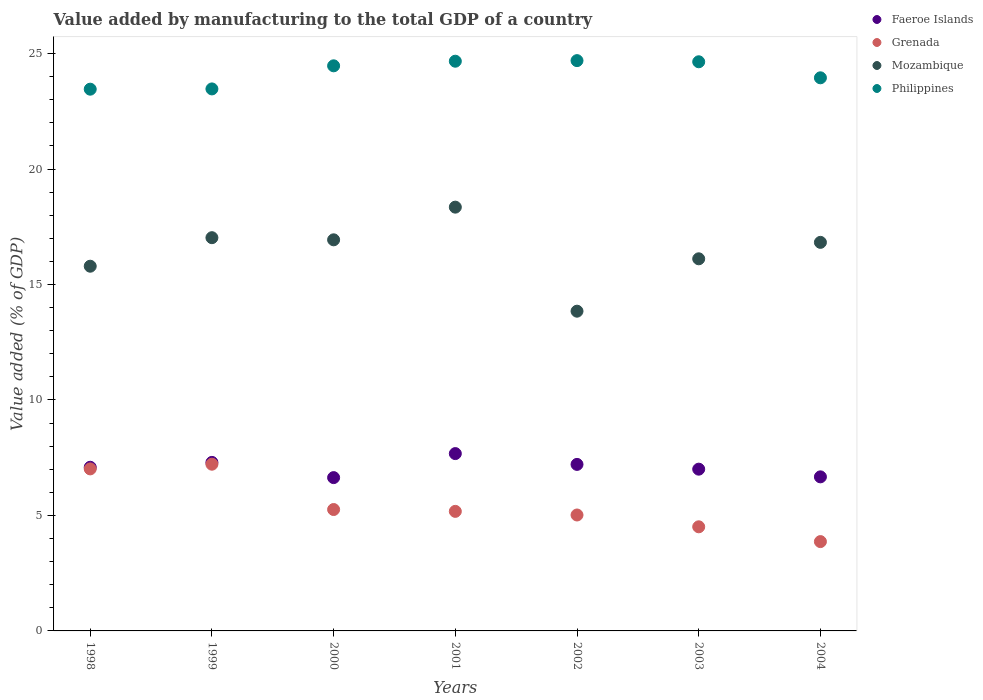How many different coloured dotlines are there?
Provide a short and direct response. 4. Is the number of dotlines equal to the number of legend labels?
Give a very brief answer. Yes. What is the value added by manufacturing to the total GDP in Mozambique in 2004?
Make the answer very short. 16.82. Across all years, what is the maximum value added by manufacturing to the total GDP in Philippines?
Provide a succinct answer. 24.69. Across all years, what is the minimum value added by manufacturing to the total GDP in Faeroe Islands?
Provide a short and direct response. 6.64. In which year was the value added by manufacturing to the total GDP in Mozambique maximum?
Ensure brevity in your answer.  2001. In which year was the value added by manufacturing to the total GDP in Faeroe Islands minimum?
Ensure brevity in your answer.  2000. What is the total value added by manufacturing to the total GDP in Mozambique in the graph?
Provide a succinct answer. 114.88. What is the difference between the value added by manufacturing to the total GDP in Grenada in 1999 and that in 2000?
Ensure brevity in your answer.  1.96. What is the difference between the value added by manufacturing to the total GDP in Faeroe Islands in 2004 and the value added by manufacturing to the total GDP in Mozambique in 2002?
Make the answer very short. -7.17. What is the average value added by manufacturing to the total GDP in Grenada per year?
Provide a short and direct response. 5.44. In the year 1998, what is the difference between the value added by manufacturing to the total GDP in Grenada and value added by manufacturing to the total GDP in Faeroe Islands?
Your answer should be very brief. -0.07. In how many years, is the value added by manufacturing to the total GDP in Philippines greater than 7 %?
Provide a short and direct response. 7. What is the ratio of the value added by manufacturing to the total GDP in Faeroe Islands in 2000 to that in 2004?
Your answer should be very brief. 1. Is the value added by manufacturing to the total GDP in Grenada in 2002 less than that in 2003?
Your answer should be very brief. No. Is the difference between the value added by manufacturing to the total GDP in Grenada in 1999 and 2000 greater than the difference between the value added by manufacturing to the total GDP in Faeroe Islands in 1999 and 2000?
Your answer should be compact. Yes. What is the difference between the highest and the second highest value added by manufacturing to the total GDP in Mozambique?
Offer a very short reply. 1.32. What is the difference between the highest and the lowest value added by manufacturing to the total GDP in Mozambique?
Give a very brief answer. 4.5. In how many years, is the value added by manufacturing to the total GDP in Faeroe Islands greater than the average value added by manufacturing to the total GDP in Faeroe Islands taken over all years?
Your answer should be very brief. 4. Is it the case that in every year, the sum of the value added by manufacturing to the total GDP in Philippines and value added by manufacturing to the total GDP in Grenada  is greater than the value added by manufacturing to the total GDP in Mozambique?
Offer a terse response. Yes. Is the value added by manufacturing to the total GDP in Grenada strictly greater than the value added by manufacturing to the total GDP in Philippines over the years?
Your answer should be compact. No. How many dotlines are there?
Ensure brevity in your answer.  4. Are the values on the major ticks of Y-axis written in scientific E-notation?
Make the answer very short. No. Does the graph contain any zero values?
Offer a very short reply. No. How are the legend labels stacked?
Keep it short and to the point. Vertical. What is the title of the graph?
Keep it short and to the point. Value added by manufacturing to the total GDP of a country. Does "Cameroon" appear as one of the legend labels in the graph?
Provide a succinct answer. No. What is the label or title of the Y-axis?
Offer a terse response. Value added (% of GDP). What is the Value added (% of GDP) of Faeroe Islands in 1998?
Your response must be concise. 7.09. What is the Value added (% of GDP) in Grenada in 1998?
Keep it short and to the point. 7.02. What is the Value added (% of GDP) in Mozambique in 1998?
Provide a succinct answer. 15.79. What is the Value added (% of GDP) in Philippines in 1998?
Keep it short and to the point. 23.46. What is the Value added (% of GDP) of Faeroe Islands in 1999?
Provide a succinct answer. 7.3. What is the Value added (% of GDP) in Grenada in 1999?
Give a very brief answer. 7.22. What is the Value added (% of GDP) in Mozambique in 1999?
Provide a short and direct response. 17.03. What is the Value added (% of GDP) of Philippines in 1999?
Keep it short and to the point. 23.47. What is the Value added (% of GDP) of Faeroe Islands in 2000?
Offer a terse response. 6.64. What is the Value added (% of GDP) in Grenada in 2000?
Give a very brief answer. 5.26. What is the Value added (% of GDP) in Mozambique in 2000?
Your response must be concise. 16.93. What is the Value added (% of GDP) of Philippines in 2000?
Make the answer very short. 24.47. What is the Value added (% of GDP) of Faeroe Islands in 2001?
Provide a short and direct response. 7.68. What is the Value added (% of GDP) of Grenada in 2001?
Make the answer very short. 5.18. What is the Value added (% of GDP) in Mozambique in 2001?
Make the answer very short. 18.35. What is the Value added (% of GDP) in Philippines in 2001?
Provide a short and direct response. 24.67. What is the Value added (% of GDP) of Faeroe Islands in 2002?
Provide a succinct answer. 7.21. What is the Value added (% of GDP) in Grenada in 2002?
Offer a terse response. 5.02. What is the Value added (% of GDP) in Mozambique in 2002?
Your answer should be very brief. 13.84. What is the Value added (% of GDP) of Philippines in 2002?
Offer a very short reply. 24.69. What is the Value added (% of GDP) of Faeroe Islands in 2003?
Provide a short and direct response. 7. What is the Value added (% of GDP) of Grenada in 2003?
Ensure brevity in your answer.  4.51. What is the Value added (% of GDP) of Mozambique in 2003?
Your answer should be compact. 16.11. What is the Value added (% of GDP) of Philippines in 2003?
Keep it short and to the point. 24.64. What is the Value added (% of GDP) of Faeroe Islands in 2004?
Ensure brevity in your answer.  6.67. What is the Value added (% of GDP) of Grenada in 2004?
Provide a succinct answer. 3.87. What is the Value added (% of GDP) in Mozambique in 2004?
Make the answer very short. 16.82. What is the Value added (% of GDP) in Philippines in 2004?
Make the answer very short. 23.95. Across all years, what is the maximum Value added (% of GDP) in Faeroe Islands?
Provide a short and direct response. 7.68. Across all years, what is the maximum Value added (% of GDP) of Grenada?
Provide a short and direct response. 7.22. Across all years, what is the maximum Value added (% of GDP) in Mozambique?
Your answer should be very brief. 18.35. Across all years, what is the maximum Value added (% of GDP) of Philippines?
Ensure brevity in your answer.  24.69. Across all years, what is the minimum Value added (% of GDP) of Faeroe Islands?
Make the answer very short. 6.64. Across all years, what is the minimum Value added (% of GDP) of Grenada?
Offer a terse response. 3.87. Across all years, what is the minimum Value added (% of GDP) in Mozambique?
Provide a succinct answer. 13.84. Across all years, what is the minimum Value added (% of GDP) of Philippines?
Give a very brief answer. 23.46. What is the total Value added (% of GDP) of Faeroe Islands in the graph?
Your answer should be compact. 49.58. What is the total Value added (% of GDP) in Grenada in the graph?
Offer a terse response. 38.06. What is the total Value added (% of GDP) in Mozambique in the graph?
Your answer should be compact. 114.88. What is the total Value added (% of GDP) of Philippines in the graph?
Ensure brevity in your answer.  169.34. What is the difference between the Value added (% of GDP) of Faeroe Islands in 1998 and that in 1999?
Provide a succinct answer. -0.21. What is the difference between the Value added (% of GDP) in Grenada in 1998 and that in 1999?
Offer a very short reply. -0.2. What is the difference between the Value added (% of GDP) of Mozambique in 1998 and that in 1999?
Provide a succinct answer. -1.24. What is the difference between the Value added (% of GDP) of Philippines in 1998 and that in 1999?
Offer a very short reply. -0.01. What is the difference between the Value added (% of GDP) of Faeroe Islands in 1998 and that in 2000?
Offer a terse response. 0.45. What is the difference between the Value added (% of GDP) in Grenada in 1998 and that in 2000?
Provide a succinct answer. 1.76. What is the difference between the Value added (% of GDP) of Mozambique in 1998 and that in 2000?
Provide a short and direct response. -1.14. What is the difference between the Value added (% of GDP) of Philippines in 1998 and that in 2000?
Your answer should be very brief. -1.01. What is the difference between the Value added (% of GDP) in Faeroe Islands in 1998 and that in 2001?
Make the answer very short. -0.59. What is the difference between the Value added (% of GDP) of Grenada in 1998 and that in 2001?
Ensure brevity in your answer.  1.84. What is the difference between the Value added (% of GDP) in Mozambique in 1998 and that in 2001?
Give a very brief answer. -2.56. What is the difference between the Value added (% of GDP) of Philippines in 1998 and that in 2001?
Your response must be concise. -1.21. What is the difference between the Value added (% of GDP) of Faeroe Islands in 1998 and that in 2002?
Make the answer very short. -0.12. What is the difference between the Value added (% of GDP) of Grenada in 1998 and that in 2002?
Your response must be concise. 2. What is the difference between the Value added (% of GDP) of Mozambique in 1998 and that in 2002?
Your answer should be compact. 1.95. What is the difference between the Value added (% of GDP) in Philippines in 1998 and that in 2002?
Ensure brevity in your answer.  -1.24. What is the difference between the Value added (% of GDP) of Faeroe Islands in 1998 and that in 2003?
Ensure brevity in your answer.  0.08. What is the difference between the Value added (% of GDP) of Grenada in 1998 and that in 2003?
Make the answer very short. 2.51. What is the difference between the Value added (% of GDP) in Mozambique in 1998 and that in 2003?
Your answer should be compact. -0.32. What is the difference between the Value added (% of GDP) in Philippines in 1998 and that in 2003?
Your answer should be compact. -1.19. What is the difference between the Value added (% of GDP) of Faeroe Islands in 1998 and that in 2004?
Your answer should be compact. 0.42. What is the difference between the Value added (% of GDP) in Grenada in 1998 and that in 2004?
Ensure brevity in your answer.  3.15. What is the difference between the Value added (% of GDP) in Mozambique in 1998 and that in 2004?
Keep it short and to the point. -1.03. What is the difference between the Value added (% of GDP) in Philippines in 1998 and that in 2004?
Your answer should be very brief. -0.49. What is the difference between the Value added (% of GDP) in Faeroe Islands in 1999 and that in 2000?
Give a very brief answer. 0.66. What is the difference between the Value added (% of GDP) of Grenada in 1999 and that in 2000?
Your answer should be very brief. 1.96. What is the difference between the Value added (% of GDP) in Mozambique in 1999 and that in 2000?
Offer a terse response. 0.09. What is the difference between the Value added (% of GDP) in Philippines in 1999 and that in 2000?
Provide a succinct answer. -1. What is the difference between the Value added (% of GDP) in Faeroe Islands in 1999 and that in 2001?
Offer a terse response. -0.38. What is the difference between the Value added (% of GDP) in Grenada in 1999 and that in 2001?
Provide a succinct answer. 2.04. What is the difference between the Value added (% of GDP) of Mozambique in 1999 and that in 2001?
Your answer should be very brief. -1.32. What is the difference between the Value added (% of GDP) of Philippines in 1999 and that in 2001?
Make the answer very short. -1.2. What is the difference between the Value added (% of GDP) in Faeroe Islands in 1999 and that in 2002?
Give a very brief answer. 0.09. What is the difference between the Value added (% of GDP) in Grenada in 1999 and that in 2002?
Your answer should be compact. 2.2. What is the difference between the Value added (% of GDP) of Mozambique in 1999 and that in 2002?
Ensure brevity in your answer.  3.18. What is the difference between the Value added (% of GDP) of Philippines in 1999 and that in 2002?
Offer a terse response. -1.23. What is the difference between the Value added (% of GDP) of Faeroe Islands in 1999 and that in 2003?
Make the answer very short. 0.29. What is the difference between the Value added (% of GDP) of Grenada in 1999 and that in 2003?
Offer a very short reply. 2.71. What is the difference between the Value added (% of GDP) in Mozambique in 1999 and that in 2003?
Offer a terse response. 0.91. What is the difference between the Value added (% of GDP) of Philippines in 1999 and that in 2003?
Keep it short and to the point. -1.18. What is the difference between the Value added (% of GDP) of Faeroe Islands in 1999 and that in 2004?
Your response must be concise. 0.63. What is the difference between the Value added (% of GDP) of Grenada in 1999 and that in 2004?
Offer a very short reply. 3.35. What is the difference between the Value added (% of GDP) in Mozambique in 1999 and that in 2004?
Your answer should be compact. 0.2. What is the difference between the Value added (% of GDP) in Philippines in 1999 and that in 2004?
Make the answer very short. -0.48. What is the difference between the Value added (% of GDP) in Faeroe Islands in 2000 and that in 2001?
Offer a terse response. -1.04. What is the difference between the Value added (% of GDP) in Grenada in 2000 and that in 2001?
Make the answer very short. 0.08. What is the difference between the Value added (% of GDP) in Mozambique in 2000 and that in 2001?
Your answer should be compact. -1.41. What is the difference between the Value added (% of GDP) in Philippines in 2000 and that in 2001?
Provide a succinct answer. -0.2. What is the difference between the Value added (% of GDP) of Faeroe Islands in 2000 and that in 2002?
Your answer should be very brief. -0.57. What is the difference between the Value added (% of GDP) in Grenada in 2000 and that in 2002?
Keep it short and to the point. 0.24. What is the difference between the Value added (% of GDP) of Mozambique in 2000 and that in 2002?
Offer a very short reply. 3.09. What is the difference between the Value added (% of GDP) of Philippines in 2000 and that in 2002?
Provide a short and direct response. -0.23. What is the difference between the Value added (% of GDP) of Faeroe Islands in 2000 and that in 2003?
Your answer should be very brief. -0.37. What is the difference between the Value added (% of GDP) of Grenada in 2000 and that in 2003?
Your answer should be very brief. 0.75. What is the difference between the Value added (% of GDP) of Mozambique in 2000 and that in 2003?
Keep it short and to the point. 0.82. What is the difference between the Value added (% of GDP) in Philippines in 2000 and that in 2003?
Your answer should be very brief. -0.18. What is the difference between the Value added (% of GDP) of Faeroe Islands in 2000 and that in 2004?
Provide a short and direct response. -0.03. What is the difference between the Value added (% of GDP) in Grenada in 2000 and that in 2004?
Give a very brief answer. 1.39. What is the difference between the Value added (% of GDP) in Mozambique in 2000 and that in 2004?
Your response must be concise. 0.11. What is the difference between the Value added (% of GDP) of Philippines in 2000 and that in 2004?
Your answer should be very brief. 0.52. What is the difference between the Value added (% of GDP) of Faeroe Islands in 2001 and that in 2002?
Provide a short and direct response. 0.47. What is the difference between the Value added (% of GDP) in Grenada in 2001 and that in 2002?
Ensure brevity in your answer.  0.16. What is the difference between the Value added (% of GDP) of Mozambique in 2001 and that in 2002?
Provide a short and direct response. 4.5. What is the difference between the Value added (% of GDP) in Philippines in 2001 and that in 2002?
Offer a very short reply. -0.03. What is the difference between the Value added (% of GDP) of Faeroe Islands in 2001 and that in 2003?
Provide a short and direct response. 0.67. What is the difference between the Value added (% of GDP) of Grenada in 2001 and that in 2003?
Offer a terse response. 0.67. What is the difference between the Value added (% of GDP) in Mozambique in 2001 and that in 2003?
Offer a very short reply. 2.24. What is the difference between the Value added (% of GDP) of Philippines in 2001 and that in 2003?
Your answer should be very brief. 0.02. What is the difference between the Value added (% of GDP) of Faeroe Islands in 2001 and that in 2004?
Your answer should be very brief. 1.01. What is the difference between the Value added (% of GDP) in Grenada in 2001 and that in 2004?
Keep it short and to the point. 1.31. What is the difference between the Value added (% of GDP) in Mozambique in 2001 and that in 2004?
Offer a very short reply. 1.52. What is the difference between the Value added (% of GDP) of Philippines in 2001 and that in 2004?
Your response must be concise. 0.72. What is the difference between the Value added (% of GDP) in Faeroe Islands in 2002 and that in 2003?
Make the answer very short. 0.21. What is the difference between the Value added (% of GDP) in Grenada in 2002 and that in 2003?
Offer a terse response. 0.51. What is the difference between the Value added (% of GDP) of Mozambique in 2002 and that in 2003?
Provide a succinct answer. -2.27. What is the difference between the Value added (% of GDP) of Philippines in 2002 and that in 2003?
Your answer should be compact. 0.05. What is the difference between the Value added (% of GDP) in Faeroe Islands in 2002 and that in 2004?
Offer a terse response. 0.54. What is the difference between the Value added (% of GDP) of Grenada in 2002 and that in 2004?
Provide a succinct answer. 1.15. What is the difference between the Value added (% of GDP) of Mozambique in 2002 and that in 2004?
Offer a very short reply. -2.98. What is the difference between the Value added (% of GDP) of Philippines in 2002 and that in 2004?
Ensure brevity in your answer.  0.74. What is the difference between the Value added (% of GDP) in Faeroe Islands in 2003 and that in 2004?
Offer a very short reply. 0.33. What is the difference between the Value added (% of GDP) in Grenada in 2003 and that in 2004?
Your answer should be compact. 0.64. What is the difference between the Value added (% of GDP) of Mozambique in 2003 and that in 2004?
Offer a terse response. -0.71. What is the difference between the Value added (% of GDP) in Philippines in 2003 and that in 2004?
Your answer should be very brief. 0.69. What is the difference between the Value added (% of GDP) in Faeroe Islands in 1998 and the Value added (% of GDP) in Grenada in 1999?
Your response must be concise. -0.13. What is the difference between the Value added (% of GDP) in Faeroe Islands in 1998 and the Value added (% of GDP) in Mozambique in 1999?
Offer a very short reply. -9.94. What is the difference between the Value added (% of GDP) of Faeroe Islands in 1998 and the Value added (% of GDP) of Philippines in 1999?
Offer a terse response. -16.38. What is the difference between the Value added (% of GDP) in Grenada in 1998 and the Value added (% of GDP) in Mozambique in 1999?
Give a very brief answer. -10.01. What is the difference between the Value added (% of GDP) in Grenada in 1998 and the Value added (% of GDP) in Philippines in 1999?
Offer a very short reply. -16.45. What is the difference between the Value added (% of GDP) in Mozambique in 1998 and the Value added (% of GDP) in Philippines in 1999?
Provide a succinct answer. -7.68. What is the difference between the Value added (% of GDP) in Faeroe Islands in 1998 and the Value added (% of GDP) in Grenada in 2000?
Make the answer very short. 1.83. What is the difference between the Value added (% of GDP) in Faeroe Islands in 1998 and the Value added (% of GDP) in Mozambique in 2000?
Your answer should be very brief. -9.85. What is the difference between the Value added (% of GDP) of Faeroe Islands in 1998 and the Value added (% of GDP) of Philippines in 2000?
Provide a succinct answer. -17.38. What is the difference between the Value added (% of GDP) of Grenada in 1998 and the Value added (% of GDP) of Mozambique in 2000?
Provide a short and direct response. -9.92. What is the difference between the Value added (% of GDP) in Grenada in 1998 and the Value added (% of GDP) in Philippines in 2000?
Keep it short and to the point. -17.45. What is the difference between the Value added (% of GDP) in Mozambique in 1998 and the Value added (% of GDP) in Philippines in 2000?
Your answer should be very brief. -8.68. What is the difference between the Value added (% of GDP) in Faeroe Islands in 1998 and the Value added (% of GDP) in Grenada in 2001?
Your answer should be compact. 1.91. What is the difference between the Value added (% of GDP) in Faeroe Islands in 1998 and the Value added (% of GDP) in Mozambique in 2001?
Your response must be concise. -11.26. What is the difference between the Value added (% of GDP) in Faeroe Islands in 1998 and the Value added (% of GDP) in Philippines in 2001?
Your answer should be very brief. -17.58. What is the difference between the Value added (% of GDP) in Grenada in 1998 and the Value added (% of GDP) in Mozambique in 2001?
Make the answer very short. -11.33. What is the difference between the Value added (% of GDP) of Grenada in 1998 and the Value added (% of GDP) of Philippines in 2001?
Your answer should be compact. -17.65. What is the difference between the Value added (% of GDP) in Mozambique in 1998 and the Value added (% of GDP) in Philippines in 2001?
Provide a short and direct response. -8.88. What is the difference between the Value added (% of GDP) of Faeroe Islands in 1998 and the Value added (% of GDP) of Grenada in 2002?
Offer a terse response. 2.07. What is the difference between the Value added (% of GDP) of Faeroe Islands in 1998 and the Value added (% of GDP) of Mozambique in 2002?
Give a very brief answer. -6.76. What is the difference between the Value added (% of GDP) in Faeroe Islands in 1998 and the Value added (% of GDP) in Philippines in 2002?
Keep it short and to the point. -17.61. What is the difference between the Value added (% of GDP) in Grenada in 1998 and the Value added (% of GDP) in Mozambique in 2002?
Provide a short and direct response. -6.83. What is the difference between the Value added (% of GDP) of Grenada in 1998 and the Value added (% of GDP) of Philippines in 2002?
Your answer should be compact. -17.68. What is the difference between the Value added (% of GDP) of Mozambique in 1998 and the Value added (% of GDP) of Philippines in 2002?
Your answer should be compact. -8.9. What is the difference between the Value added (% of GDP) of Faeroe Islands in 1998 and the Value added (% of GDP) of Grenada in 2003?
Make the answer very short. 2.58. What is the difference between the Value added (% of GDP) of Faeroe Islands in 1998 and the Value added (% of GDP) of Mozambique in 2003?
Provide a succinct answer. -9.03. What is the difference between the Value added (% of GDP) in Faeroe Islands in 1998 and the Value added (% of GDP) in Philippines in 2003?
Make the answer very short. -17.56. What is the difference between the Value added (% of GDP) in Grenada in 1998 and the Value added (% of GDP) in Mozambique in 2003?
Offer a terse response. -9.1. What is the difference between the Value added (% of GDP) in Grenada in 1998 and the Value added (% of GDP) in Philippines in 2003?
Provide a succinct answer. -17.63. What is the difference between the Value added (% of GDP) in Mozambique in 1998 and the Value added (% of GDP) in Philippines in 2003?
Keep it short and to the point. -8.85. What is the difference between the Value added (% of GDP) of Faeroe Islands in 1998 and the Value added (% of GDP) of Grenada in 2004?
Offer a terse response. 3.22. What is the difference between the Value added (% of GDP) of Faeroe Islands in 1998 and the Value added (% of GDP) of Mozambique in 2004?
Provide a succinct answer. -9.74. What is the difference between the Value added (% of GDP) in Faeroe Islands in 1998 and the Value added (% of GDP) in Philippines in 2004?
Keep it short and to the point. -16.86. What is the difference between the Value added (% of GDP) in Grenada in 1998 and the Value added (% of GDP) in Mozambique in 2004?
Keep it short and to the point. -9.81. What is the difference between the Value added (% of GDP) of Grenada in 1998 and the Value added (% of GDP) of Philippines in 2004?
Offer a terse response. -16.93. What is the difference between the Value added (% of GDP) of Mozambique in 1998 and the Value added (% of GDP) of Philippines in 2004?
Keep it short and to the point. -8.16. What is the difference between the Value added (% of GDP) in Faeroe Islands in 1999 and the Value added (% of GDP) in Grenada in 2000?
Offer a very short reply. 2.04. What is the difference between the Value added (% of GDP) of Faeroe Islands in 1999 and the Value added (% of GDP) of Mozambique in 2000?
Offer a terse response. -9.64. What is the difference between the Value added (% of GDP) in Faeroe Islands in 1999 and the Value added (% of GDP) in Philippines in 2000?
Offer a very short reply. -17.17. What is the difference between the Value added (% of GDP) of Grenada in 1999 and the Value added (% of GDP) of Mozambique in 2000?
Your answer should be compact. -9.72. What is the difference between the Value added (% of GDP) in Grenada in 1999 and the Value added (% of GDP) in Philippines in 2000?
Keep it short and to the point. -17.25. What is the difference between the Value added (% of GDP) of Mozambique in 1999 and the Value added (% of GDP) of Philippines in 2000?
Offer a very short reply. -7.44. What is the difference between the Value added (% of GDP) of Faeroe Islands in 1999 and the Value added (% of GDP) of Grenada in 2001?
Offer a terse response. 2.12. What is the difference between the Value added (% of GDP) of Faeroe Islands in 1999 and the Value added (% of GDP) of Mozambique in 2001?
Provide a succinct answer. -11.05. What is the difference between the Value added (% of GDP) of Faeroe Islands in 1999 and the Value added (% of GDP) of Philippines in 2001?
Ensure brevity in your answer.  -17.37. What is the difference between the Value added (% of GDP) of Grenada in 1999 and the Value added (% of GDP) of Mozambique in 2001?
Keep it short and to the point. -11.13. What is the difference between the Value added (% of GDP) in Grenada in 1999 and the Value added (% of GDP) in Philippines in 2001?
Your answer should be very brief. -17.45. What is the difference between the Value added (% of GDP) of Mozambique in 1999 and the Value added (% of GDP) of Philippines in 2001?
Offer a terse response. -7.64. What is the difference between the Value added (% of GDP) in Faeroe Islands in 1999 and the Value added (% of GDP) in Grenada in 2002?
Keep it short and to the point. 2.28. What is the difference between the Value added (% of GDP) in Faeroe Islands in 1999 and the Value added (% of GDP) in Mozambique in 2002?
Offer a very short reply. -6.55. What is the difference between the Value added (% of GDP) of Faeroe Islands in 1999 and the Value added (% of GDP) of Philippines in 2002?
Offer a terse response. -17.4. What is the difference between the Value added (% of GDP) of Grenada in 1999 and the Value added (% of GDP) of Mozambique in 2002?
Make the answer very short. -6.63. What is the difference between the Value added (% of GDP) in Grenada in 1999 and the Value added (% of GDP) in Philippines in 2002?
Give a very brief answer. -17.47. What is the difference between the Value added (% of GDP) of Mozambique in 1999 and the Value added (% of GDP) of Philippines in 2002?
Give a very brief answer. -7.67. What is the difference between the Value added (% of GDP) in Faeroe Islands in 1999 and the Value added (% of GDP) in Grenada in 2003?
Offer a very short reply. 2.79. What is the difference between the Value added (% of GDP) in Faeroe Islands in 1999 and the Value added (% of GDP) in Mozambique in 2003?
Your answer should be compact. -8.82. What is the difference between the Value added (% of GDP) in Faeroe Islands in 1999 and the Value added (% of GDP) in Philippines in 2003?
Give a very brief answer. -17.35. What is the difference between the Value added (% of GDP) of Grenada in 1999 and the Value added (% of GDP) of Mozambique in 2003?
Your response must be concise. -8.89. What is the difference between the Value added (% of GDP) in Grenada in 1999 and the Value added (% of GDP) in Philippines in 2003?
Keep it short and to the point. -17.42. What is the difference between the Value added (% of GDP) of Mozambique in 1999 and the Value added (% of GDP) of Philippines in 2003?
Keep it short and to the point. -7.62. What is the difference between the Value added (% of GDP) in Faeroe Islands in 1999 and the Value added (% of GDP) in Grenada in 2004?
Your answer should be compact. 3.43. What is the difference between the Value added (% of GDP) in Faeroe Islands in 1999 and the Value added (% of GDP) in Mozambique in 2004?
Provide a short and direct response. -9.53. What is the difference between the Value added (% of GDP) in Faeroe Islands in 1999 and the Value added (% of GDP) in Philippines in 2004?
Give a very brief answer. -16.65. What is the difference between the Value added (% of GDP) in Grenada in 1999 and the Value added (% of GDP) in Mozambique in 2004?
Provide a short and direct response. -9.61. What is the difference between the Value added (% of GDP) of Grenada in 1999 and the Value added (% of GDP) of Philippines in 2004?
Make the answer very short. -16.73. What is the difference between the Value added (% of GDP) of Mozambique in 1999 and the Value added (% of GDP) of Philippines in 2004?
Make the answer very short. -6.92. What is the difference between the Value added (% of GDP) in Faeroe Islands in 2000 and the Value added (% of GDP) in Grenada in 2001?
Your response must be concise. 1.46. What is the difference between the Value added (% of GDP) in Faeroe Islands in 2000 and the Value added (% of GDP) in Mozambique in 2001?
Your answer should be very brief. -11.71. What is the difference between the Value added (% of GDP) in Faeroe Islands in 2000 and the Value added (% of GDP) in Philippines in 2001?
Ensure brevity in your answer.  -18.03. What is the difference between the Value added (% of GDP) of Grenada in 2000 and the Value added (% of GDP) of Mozambique in 2001?
Make the answer very short. -13.09. What is the difference between the Value added (% of GDP) of Grenada in 2000 and the Value added (% of GDP) of Philippines in 2001?
Keep it short and to the point. -19.41. What is the difference between the Value added (% of GDP) of Mozambique in 2000 and the Value added (% of GDP) of Philippines in 2001?
Give a very brief answer. -7.73. What is the difference between the Value added (% of GDP) of Faeroe Islands in 2000 and the Value added (% of GDP) of Grenada in 2002?
Make the answer very short. 1.62. What is the difference between the Value added (% of GDP) of Faeroe Islands in 2000 and the Value added (% of GDP) of Mozambique in 2002?
Ensure brevity in your answer.  -7.21. What is the difference between the Value added (% of GDP) in Faeroe Islands in 2000 and the Value added (% of GDP) in Philippines in 2002?
Give a very brief answer. -18.05. What is the difference between the Value added (% of GDP) in Grenada in 2000 and the Value added (% of GDP) in Mozambique in 2002?
Give a very brief answer. -8.59. What is the difference between the Value added (% of GDP) of Grenada in 2000 and the Value added (% of GDP) of Philippines in 2002?
Provide a short and direct response. -19.44. What is the difference between the Value added (% of GDP) in Mozambique in 2000 and the Value added (% of GDP) in Philippines in 2002?
Offer a terse response. -7.76. What is the difference between the Value added (% of GDP) of Faeroe Islands in 2000 and the Value added (% of GDP) of Grenada in 2003?
Your answer should be very brief. 2.13. What is the difference between the Value added (% of GDP) of Faeroe Islands in 2000 and the Value added (% of GDP) of Mozambique in 2003?
Make the answer very short. -9.47. What is the difference between the Value added (% of GDP) of Faeroe Islands in 2000 and the Value added (% of GDP) of Philippines in 2003?
Offer a terse response. -18. What is the difference between the Value added (% of GDP) of Grenada in 2000 and the Value added (% of GDP) of Mozambique in 2003?
Your response must be concise. -10.86. What is the difference between the Value added (% of GDP) in Grenada in 2000 and the Value added (% of GDP) in Philippines in 2003?
Give a very brief answer. -19.39. What is the difference between the Value added (% of GDP) in Mozambique in 2000 and the Value added (% of GDP) in Philippines in 2003?
Keep it short and to the point. -7.71. What is the difference between the Value added (% of GDP) in Faeroe Islands in 2000 and the Value added (% of GDP) in Grenada in 2004?
Provide a succinct answer. 2.77. What is the difference between the Value added (% of GDP) of Faeroe Islands in 2000 and the Value added (% of GDP) of Mozambique in 2004?
Give a very brief answer. -10.19. What is the difference between the Value added (% of GDP) of Faeroe Islands in 2000 and the Value added (% of GDP) of Philippines in 2004?
Give a very brief answer. -17.31. What is the difference between the Value added (% of GDP) of Grenada in 2000 and the Value added (% of GDP) of Mozambique in 2004?
Provide a succinct answer. -11.57. What is the difference between the Value added (% of GDP) in Grenada in 2000 and the Value added (% of GDP) in Philippines in 2004?
Your answer should be very brief. -18.69. What is the difference between the Value added (% of GDP) in Mozambique in 2000 and the Value added (% of GDP) in Philippines in 2004?
Make the answer very short. -7.01. What is the difference between the Value added (% of GDP) of Faeroe Islands in 2001 and the Value added (% of GDP) of Grenada in 2002?
Offer a terse response. 2.66. What is the difference between the Value added (% of GDP) of Faeroe Islands in 2001 and the Value added (% of GDP) of Mozambique in 2002?
Provide a short and direct response. -6.17. What is the difference between the Value added (% of GDP) of Faeroe Islands in 2001 and the Value added (% of GDP) of Philippines in 2002?
Ensure brevity in your answer.  -17.01. What is the difference between the Value added (% of GDP) of Grenada in 2001 and the Value added (% of GDP) of Mozambique in 2002?
Offer a terse response. -8.67. What is the difference between the Value added (% of GDP) of Grenada in 2001 and the Value added (% of GDP) of Philippines in 2002?
Your response must be concise. -19.52. What is the difference between the Value added (% of GDP) of Mozambique in 2001 and the Value added (% of GDP) of Philippines in 2002?
Give a very brief answer. -6.34. What is the difference between the Value added (% of GDP) of Faeroe Islands in 2001 and the Value added (% of GDP) of Grenada in 2003?
Your answer should be very brief. 3.17. What is the difference between the Value added (% of GDP) in Faeroe Islands in 2001 and the Value added (% of GDP) in Mozambique in 2003?
Your answer should be compact. -8.43. What is the difference between the Value added (% of GDP) of Faeroe Islands in 2001 and the Value added (% of GDP) of Philippines in 2003?
Offer a terse response. -16.96. What is the difference between the Value added (% of GDP) of Grenada in 2001 and the Value added (% of GDP) of Mozambique in 2003?
Give a very brief answer. -10.94. What is the difference between the Value added (% of GDP) in Grenada in 2001 and the Value added (% of GDP) in Philippines in 2003?
Offer a terse response. -19.47. What is the difference between the Value added (% of GDP) in Mozambique in 2001 and the Value added (% of GDP) in Philippines in 2003?
Ensure brevity in your answer.  -6.29. What is the difference between the Value added (% of GDP) of Faeroe Islands in 2001 and the Value added (% of GDP) of Grenada in 2004?
Your response must be concise. 3.81. What is the difference between the Value added (% of GDP) in Faeroe Islands in 2001 and the Value added (% of GDP) in Mozambique in 2004?
Your answer should be very brief. -9.15. What is the difference between the Value added (% of GDP) of Faeroe Islands in 2001 and the Value added (% of GDP) of Philippines in 2004?
Ensure brevity in your answer.  -16.27. What is the difference between the Value added (% of GDP) in Grenada in 2001 and the Value added (% of GDP) in Mozambique in 2004?
Offer a very short reply. -11.65. What is the difference between the Value added (% of GDP) in Grenada in 2001 and the Value added (% of GDP) in Philippines in 2004?
Make the answer very short. -18.77. What is the difference between the Value added (% of GDP) in Mozambique in 2001 and the Value added (% of GDP) in Philippines in 2004?
Offer a very short reply. -5.6. What is the difference between the Value added (% of GDP) of Faeroe Islands in 2002 and the Value added (% of GDP) of Grenada in 2003?
Keep it short and to the point. 2.7. What is the difference between the Value added (% of GDP) of Faeroe Islands in 2002 and the Value added (% of GDP) of Mozambique in 2003?
Offer a very short reply. -8.9. What is the difference between the Value added (% of GDP) of Faeroe Islands in 2002 and the Value added (% of GDP) of Philippines in 2003?
Your answer should be compact. -17.43. What is the difference between the Value added (% of GDP) in Grenada in 2002 and the Value added (% of GDP) in Mozambique in 2003?
Keep it short and to the point. -11.09. What is the difference between the Value added (% of GDP) of Grenada in 2002 and the Value added (% of GDP) of Philippines in 2003?
Keep it short and to the point. -19.62. What is the difference between the Value added (% of GDP) in Mozambique in 2002 and the Value added (% of GDP) in Philippines in 2003?
Keep it short and to the point. -10.8. What is the difference between the Value added (% of GDP) of Faeroe Islands in 2002 and the Value added (% of GDP) of Grenada in 2004?
Provide a succinct answer. 3.34. What is the difference between the Value added (% of GDP) of Faeroe Islands in 2002 and the Value added (% of GDP) of Mozambique in 2004?
Provide a short and direct response. -9.61. What is the difference between the Value added (% of GDP) in Faeroe Islands in 2002 and the Value added (% of GDP) in Philippines in 2004?
Provide a short and direct response. -16.74. What is the difference between the Value added (% of GDP) of Grenada in 2002 and the Value added (% of GDP) of Mozambique in 2004?
Keep it short and to the point. -11.8. What is the difference between the Value added (% of GDP) in Grenada in 2002 and the Value added (% of GDP) in Philippines in 2004?
Give a very brief answer. -18.93. What is the difference between the Value added (% of GDP) of Mozambique in 2002 and the Value added (% of GDP) of Philippines in 2004?
Your answer should be very brief. -10.1. What is the difference between the Value added (% of GDP) of Faeroe Islands in 2003 and the Value added (% of GDP) of Grenada in 2004?
Provide a short and direct response. 3.14. What is the difference between the Value added (% of GDP) in Faeroe Islands in 2003 and the Value added (% of GDP) in Mozambique in 2004?
Your answer should be very brief. -9.82. What is the difference between the Value added (% of GDP) in Faeroe Islands in 2003 and the Value added (% of GDP) in Philippines in 2004?
Provide a short and direct response. -16.94. What is the difference between the Value added (% of GDP) in Grenada in 2003 and the Value added (% of GDP) in Mozambique in 2004?
Make the answer very short. -12.32. What is the difference between the Value added (% of GDP) in Grenada in 2003 and the Value added (% of GDP) in Philippines in 2004?
Offer a very short reply. -19.44. What is the difference between the Value added (% of GDP) of Mozambique in 2003 and the Value added (% of GDP) of Philippines in 2004?
Give a very brief answer. -7.84. What is the average Value added (% of GDP) of Faeroe Islands per year?
Your response must be concise. 7.08. What is the average Value added (% of GDP) of Grenada per year?
Offer a terse response. 5.44. What is the average Value added (% of GDP) in Mozambique per year?
Your response must be concise. 16.41. What is the average Value added (% of GDP) in Philippines per year?
Your answer should be compact. 24.19. In the year 1998, what is the difference between the Value added (% of GDP) in Faeroe Islands and Value added (% of GDP) in Grenada?
Provide a short and direct response. 0.07. In the year 1998, what is the difference between the Value added (% of GDP) in Faeroe Islands and Value added (% of GDP) in Mozambique?
Ensure brevity in your answer.  -8.7. In the year 1998, what is the difference between the Value added (% of GDP) of Faeroe Islands and Value added (% of GDP) of Philippines?
Your response must be concise. -16.37. In the year 1998, what is the difference between the Value added (% of GDP) of Grenada and Value added (% of GDP) of Mozambique?
Provide a short and direct response. -8.78. In the year 1998, what is the difference between the Value added (% of GDP) in Grenada and Value added (% of GDP) in Philippines?
Give a very brief answer. -16.44. In the year 1998, what is the difference between the Value added (% of GDP) in Mozambique and Value added (% of GDP) in Philippines?
Ensure brevity in your answer.  -7.67. In the year 1999, what is the difference between the Value added (% of GDP) of Faeroe Islands and Value added (% of GDP) of Grenada?
Ensure brevity in your answer.  0.08. In the year 1999, what is the difference between the Value added (% of GDP) in Faeroe Islands and Value added (% of GDP) in Mozambique?
Give a very brief answer. -9.73. In the year 1999, what is the difference between the Value added (% of GDP) of Faeroe Islands and Value added (% of GDP) of Philippines?
Offer a very short reply. -16.17. In the year 1999, what is the difference between the Value added (% of GDP) in Grenada and Value added (% of GDP) in Mozambique?
Keep it short and to the point. -9.81. In the year 1999, what is the difference between the Value added (% of GDP) of Grenada and Value added (% of GDP) of Philippines?
Your answer should be very brief. -16.25. In the year 1999, what is the difference between the Value added (% of GDP) in Mozambique and Value added (% of GDP) in Philippines?
Offer a very short reply. -6.44. In the year 2000, what is the difference between the Value added (% of GDP) in Faeroe Islands and Value added (% of GDP) in Grenada?
Give a very brief answer. 1.38. In the year 2000, what is the difference between the Value added (% of GDP) in Faeroe Islands and Value added (% of GDP) in Mozambique?
Provide a short and direct response. -10.3. In the year 2000, what is the difference between the Value added (% of GDP) of Faeroe Islands and Value added (% of GDP) of Philippines?
Offer a very short reply. -17.83. In the year 2000, what is the difference between the Value added (% of GDP) of Grenada and Value added (% of GDP) of Mozambique?
Your response must be concise. -11.68. In the year 2000, what is the difference between the Value added (% of GDP) in Grenada and Value added (% of GDP) in Philippines?
Offer a very short reply. -19.21. In the year 2000, what is the difference between the Value added (% of GDP) in Mozambique and Value added (% of GDP) in Philippines?
Ensure brevity in your answer.  -7.53. In the year 2001, what is the difference between the Value added (% of GDP) in Faeroe Islands and Value added (% of GDP) in Grenada?
Offer a very short reply. 2.5. In the year 2001, what is the difference between the Value added (% of GDP) in Faeroe Islands and Value added (% of GDP) in Mozambique?
Your answer should be compact. -10.67. In the year 2001, what is the difference between the Value added (% of GDP) of Faeroe Islands and Value added (% of GDP) of Philippines?
Offer a terse response. -16.99. In the year 2001, what is the difference between the Value added (% of GDP) in Grenada and Value added (% of GDP) in Mozambique?
Ensure brevity in your answer.  -13.17. In the year 2001, what is the difference between the Value added (% of GDP) of Grenada and Value added (% of GDP) of Philippines?
Your answer should be very brief. -19.49. In the year 2001, what is the difference between the Value added (% of GDP) of Mozambique and Value added (% of GDP) of Philippines?
Give a very brief answer. -6.32. In the year 2002, what is the difference between the Value added (% of GDP) in Faeroe Islands and Value added (% of GDP) in Grenada?
Your answer should be very brief. 2.19. In the year 2002, what is the difference between the Value added (% of GDP) of Faeroe Islands and Value added (% of GDP) of Mozambique?
Your response must be concise. -6.63. In the year 2002, what is the difference between the Value added (% of GDP) in Faeroe Islands and Value added (% of GDP) in Philippines?
Ensure brevity in your answer.  -17.48. In the year 2002, what is the difference between the Value added (% of GDP) in Grenada and Value added (% of GDP) in Mozambique?
Provide a short and direct response. -8.82. In the year 2002, what is the difference between the Value added (% of GDP) of Grenada and Value added (% of GDP) of Philippines?
Ensure brevity in your answer.  -19.67. In the year 2002, what is the difference between the Value added (% of GDP) in Mozambique and Value added (% of GDP) in Philippines?
Give a very brief answer. -10.85. In the year 2003, what is the difference between the Value added (% of GDP) in Faeroe Islands and Value added (% of GDP) in Grenada?
Your response must be concise. 2.5. In the year 2003, what is the difference between the Value added (% of GDP) of Faeroe Islands and Value added (% of GDP) of Mozambique?
Keep it short and to the point. -9.11. In the year 2003, what is the difference between the Value added (% of GDP) of Faeroe Islands and Value added (% of GDP) of Philippines?
Make the answer very short. -17.64. In the year 2003, what is the difference between the Value added (% of GDP) of Grenada and Value added (% of GDP) of Mozambique?
Your answer should be compact. -11.6. In the year 2003, what is the difference between the Value added (% of GDP) of Grenada and Value added (% of GDP) of Philippines?
Provide a succinct answer. -20.13. In the year 2003, what is the difference between the Value added (% of GDP) in Mozambique and Value added (% of GDP) in Philippines?
Keep it short and to the point. -8.53. In the year 2004, what is the difference between the Value added (% of GDP) in Faeroe Islands and Value added (% of GDP) in Grenada?
Provide a short and direct response. 2.8. In the year 2004, what is the difference between the Value added (% of GDP) of Faeroe Islands and Value added (% of GDP) of Mozambique?
Offer a very short reply. -10.15. In the year 2004, what is the difference between the Value added (% of GDP) of Faeroe Islands and Value added (% of GDP) of Philippines?
Provide a succinct answer. -17.28. In the year 2004, what is the difference between the Value added (% of GDP) of Grenada and Value added (% of GDP) of Mozambique?
Your response must be concise. -12.96. In the year 2004, what is the difference between the Value added (% of GDP) in Grenada and Value added (% of GDP) in Philippines?
Offer a very short reply. -20.08. In the year 2004, what is the difference between the Value added (% of GDP) in Mozambique and Value added (% of GDP) in Philippines?
Give a very brief answer. -7.12. What is the ratio of the Value added (% of GDP) in Faeroe Islands in 1998 to that in 1999?
Ensure brevity in your answer.  0.97. What is the ratio of the Value added (% of GDP) of Grenada in 1998 to that in 1999?
Your answer should be very brief. 0.97. What is the ratio of the Value added (% of GDP) of Mozambique in 1998 to that in 1999?
Keep it short and to the point. 0.93. What is the ratio of the Value added (% of GDP) of Faeroe Islands in 1998 to that in 2000?
Keep it short and to the point. 1.07. What is the ratio of the Value added (% of GDP) of Grenada in 1998 to that in 2000?
Offer a very short reply. 1.33. What is the ratio of the Value added (% of GDP) of Mozambique in 1998 to that in 2000?
Keep it short and to the point. 0.93. What is the ratio of the Value added (% of GDP) in Philippines in 1998 to that in 2000?
Offer a terse response. 0.96. What is the ratio of the Value added (% of GDP) in Faeroe Islands in 1998 to that in 2001?
Your response must be concise. 0.92. What is the ratio of the Value added (% of GDP) of Grenada in 1998 to that in 2001?
Ensure brevity in your answer.  1.36. What is the ratio of the Value added (% of GDP) in Mozambique in 1998 to that in 2001?
Give a very brief answer. 0.86. What is the ratio of the Value added (% of GDP) of Philippines in 1998 to that in 2001?
Provide a short and direct response. 0.95. What is the ratio of the Value added (% of GDP) in Faeroe Islands in 1998 to that in 2002?
Your answer should be very brief. 0.98. What is the ratio of the Value added (% of GDP) in Grenada in 1998 to that in 2002?
Offer a terse response. 1.4. What is the ratio of the Value added (% of GDP) of Mozambique in 1998 to that in 2002?
Provide a short and direct response. 1.14. What is the ratio of the Value added (% of GDP) of Philippines in 1998 to that in 2002?
Your response must be concise. 0.95. What is the ratio of the Value added (% of GDP) in Faeroe Islands in 1998 to that in 2003?
Give a very brief answer. 1.01. What is the ratio of the Value added (% of GDP) of Grenada in 1998 to that in 2003?
Give a very brief answer. 1.56. What is the ratio of the Value added (% of GDP) of Mozambique in 1998 to that in 2003?
Give a very brief answer. 0.98. What is the ratio of the Value added (% of GDP) in Philippines in 1998 to that in 2003?
Your answer should be very brief. 0.95. What is the ratio of the Value added (% of GDP) of Faeroe Islands in 1998 to that in 2004?
Give a very brief answer. 1.06. What is the ratio of the Value added (% of GDP) of Grenada in 1998 to that in 2004?
Provide a succinct answer. 1.81. What is the ratio of the Value added (% of GDP) in Mozambique in 1998 to that in 2004?
Give a very brief answer. 0.94. What is the ratio of the Value added (% of GDP) in Philippines in 1998 to that in 2004?
Keep it short and to the point. 0.98. What is the ratio of the Value added (% of GDP) of Faeroe Islands in 1999 to that in 2000?
Make the answer very short. 1.1. What is the ratio of the Value added (% of GDP) in Grenada in 1999 to that in 2000?
Your response must be concise. 1.37. What is the ratio of the Value added (% of GDP) in Mozambique in 1999 to that in 2000?
Your response must be concise. 1.01. What is the ratio of the Value added (% of GDP) in Philippines in 1999 to that in 2000?
Give a very brief answer. 0.96. What is the ratio of the Value added (% of GDP) of Faeroe Islands in 1999 to that in 2001?
Your answer should be compact. 0.95. What is the ratio of the Value added (% of GDP) in Grenada in 1999 to that in 2001?
Keep it short and to the point. 1.39. What is the ratio of the Value added (% of GDP) of Mozambique in 1999 to that in 2001?
Provide a short and direct response. 0.93. What is the ratio of the Value added (% of GDP) of Philippines in 1999 to that in 2001?
Your answer should be very brief. 0.95. What is the ratio of the Value added (% of GDP) of Faeroe Islands in 1999 to that in 2002?
Give a very brief answer. 1.01. What is the ratio of the Value added (% of GDP) in Grenada in 1999 to that in 2002?
Keep it short and to the point. 1.44. What is the ratio of the Value added (% of GDP) in Mozambique in 1999 to that in 2002?
Make the answer very short. 1.23. What is the ratio of the Value added (% of GDP) in Philippines in 1999 to that in 2002?
Your response must be concise. 0.95. What is the ratio of the Value added (% of GDP) in Faeroe Islands in 1999 to that in 2003?
Provide a succinct answer. 1.04. What is the ratio of the Value added (% of GDP) in Grenada in 1999 to that in 2003?
Make the answer very short. 1.6. What is the ratio of the Value added (% of GDP) in Mozambique in 1999 to that in 2003?
Keep it short and to the point. 1.06. What is the ratio of the Value added (% of GDP) of Philippines in 1999 to that in 2003?
Offer a terse response. 0.95. What is the ratio of the Value added (% of GDP) in Faeroe Islands in 1999 to that in 2004?
Keep it short and to the point. 1.09. What is the ratio of the Value added (% of GDP) in Grenada in 1999 to that in 2004?
Provide a short and direct response. 1.87. What is the ratio of the Value added (% of GDP) in Philippines in 1999 to that in 2004?
Offer a terse response. 0.98. What is the ratio of the Value added (% of GDP) of Faeroe Islands in 2000 to that in 2001?
Ensure brevity in your answer.  0.86. What is the ratio of the Value added (% of GDP) in Grenada in 2000 to that in 2001?
Make the answer very short. 1.02. What is the ratio of the Value added (% of GDP) in Mozambique in 2000 to that in 2001?
Provide a succinct answer. 0.92. What is the ratio of the Value added (% of GDP) in Philippines in 2000 to that in 2001?
Offer a terse response. 0.99. What is the ratio of the Value added (% of GDP) of Faeroe Islands in 2000 to that in 2002?
Give a very brief answer. 0.92. What is the ratio of the Value added (% of GDP) in Grenada in 2000 to that in 2002?
Provide a succinct answer. 1.05. What is the ratio of the Value added (% of GDP) in Mozambique in 2000 to that in 2002?
Ensure brevity in your answer.  1.22. What is the ratio of the Value added (% of GDP) in Philippines in 2000 to that in 2002?
Offer a terse response. 0.99. What is the ratio of the Value added (% of GDP) of Faeroe Islands in 2000 to that in 2003?
Give a very brief answer. 0.95. What is the ratio of the Value added (% of GDP) of Grenada in 2000 to that in 2003?
Ensure brevity in your answer.  1.17. What is the ratio of the Value added (% of GDP) of Mozambique in 2000 to that in 2003?
Keep it short and to the point. 1.05. What is the ratio of the Value added (% of GDP) of Grenada in 2000 to that in 2004?
Your answer should be compact. 1.36. What is the ratio of the Value added (% of GDP) in Philippines in 2000 to that in 2004?
Keep it short and to the point. 1.02. What is the ratio of the Value added (% of GDP) of Faeroe Islands in 2001 to that in 2002?
Ensure brevity in your answer.  1.06. What is the ratio of the Value added (% of GDP) in Grenada in 2001 to that in 2002?
Keep it short and to the point. 1.03. What is the ratio of the Value added (% of GDP) in Mozambique in 2001 to that in 2002?
Provide a succinct answer. 1.33. What is the ratio of the Value added (% of GDP) in Faeroe Islands in 2001 to that in 2003?
Keep it short and to the point. 1.1. What is the ratio of the Value added (% of GDP) of Grenada in 2001 to that in 2003?
Offer a terse response. 1.15. What is the ratio of the Value added (% of GDP) of Mozambique in 2001 to that in 2003?
Make the answer very short. 1.14. What is the ratio of the Value added (% of GDP) in Faeroe Islands in 2001 to that in 2004?
Keep it short and to the point. 1.15. What is the ratio of the Value added (% of GDP) in Grenada in 2001 to that in 2004?
Provide a succinct answer. 1.34. What is the ratio of the Value added (% of GDP) in Mozambique in 2001 to that in 2004?
Your response must be concise. 1.09. What is the ratio of the Value added (% of GDP) in Philippines in 2001 to that in 2004?
Make the answer very short. 1.03. What is the ratio of the Value added (% of GDP) in Faeroe Islands in 2002 to that in 2003?
Keep it short and to the point. 1.03. What is the ratio of the Value added (% of GDP) in Grenada in 2002 to that in 2003?
Offer a very short reply. 1.11. What is the ratio of the Value added (% of GDP) in Mozambique in 2002 to that in 2003?
Give a very brief answer. 0.86. What is the ratio of the Value added (% of GDP) in Faeroe Islands in 2002 to that in 2004?
Give a very brief answer. 1.08. What is the ratio of the Value added (% of GDP) of Grenada in 2002 to that in 2004?
Offer a very short reply. 1.3. What is the ratio of the Value added (% of GDP) in Mozambique in 2002 to that in 2004?
Your answer should be very brief. 0.82. What is the ratio of the Value added (% of GDP) of Philippines in 2002 to that in 2004?
Keep it short and to the point. 1.03. What is the ratio of the Value added (% of GDP) in Faeroe Islands in 2003 to that in 2004?
Your answer should be compact. 1.05. What is the ratio of the Value added (% of GDP) of Grenada in 2003 to that in 2004?
Ensure brevity in your answer.  1.17. What is the ratio of the Value added (% of GDP) of Mozambique in 2003 to that in 2004?
Keep it short and to the point. 0.96. What is the ratio of the Value added (% of GDP) of Philippines in 2003 to that in 2004?
Provide a short and direct response. 1.03. What is the difference between the highest and the second highest Value added (% of GDP) of Faeroe Islands?
Your response must be concise. 0.38. What is the difference between the highest and the second highest Value added (% of GDP) in Grenada?
Make the answer very short. 0.2. What is the difference between the highest and the second highest Value added (% of GDP) in Mozambique?
Your answer should be compact. 1.32. What is the difference between the highest and the second highest Value added (% of GDP) in Philippines?
Your response must be concise. 0.03. What is the difference between the highest and the lowest Value added (% of GDP) in Faeroe Islands?
Your answer should be very brief. 1.04. What is the difference between the highest and the lowest Value added (% of GDP) of Grenada?
Keep it short and to the point. 3.35. What is the difference between the highest and the lowest Value added (% of GDP) in Mozambique?
Your response must be concise. 4.5. What is the difference between the highest and the lowest Value added (% of GDP) of Philippines?
Ensure brevity in your answer.  1.24. 